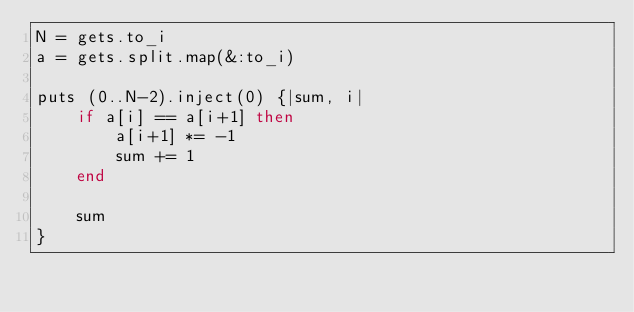Convert code to text. <code><loc_0><loc_0><loc_500><loc_500><_Ruby_>N = gets.to_i
a = gets.split.map(&:to_i)

puts (0..N-2).inject(0) {|sum, i|
    if a[i] == a[i+1] then
        a[i+1] *= -1
        sum += 1
    end
    
    sum
}</code> 